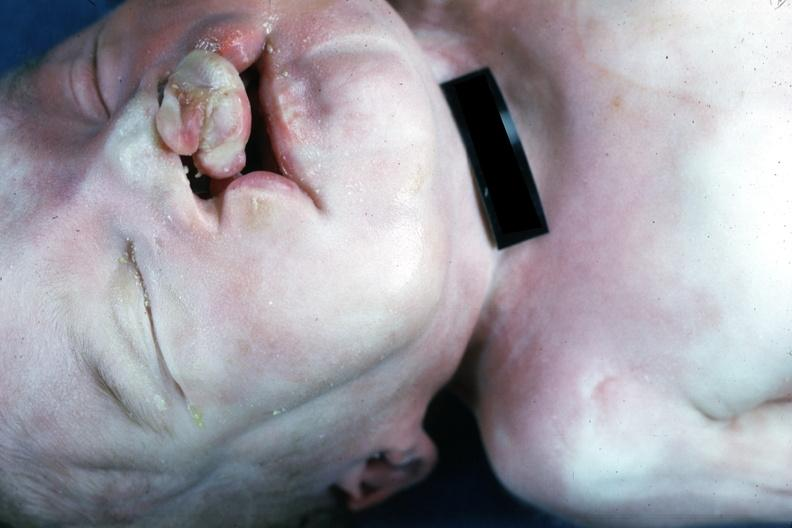does cytomegalovirus show external view bilateral cleft palate?
Answer the question using a single word or phrase. No 